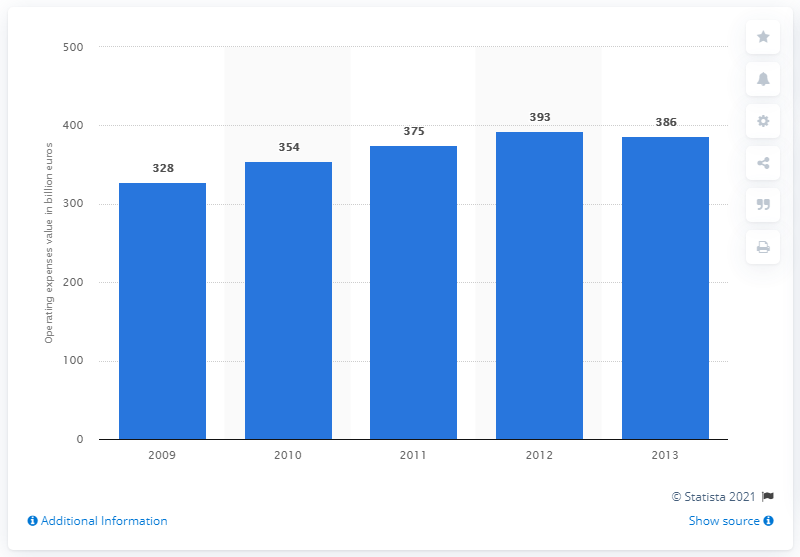Point out several critical features in this image. The operating expenses of European banks in 2013 were 386. 